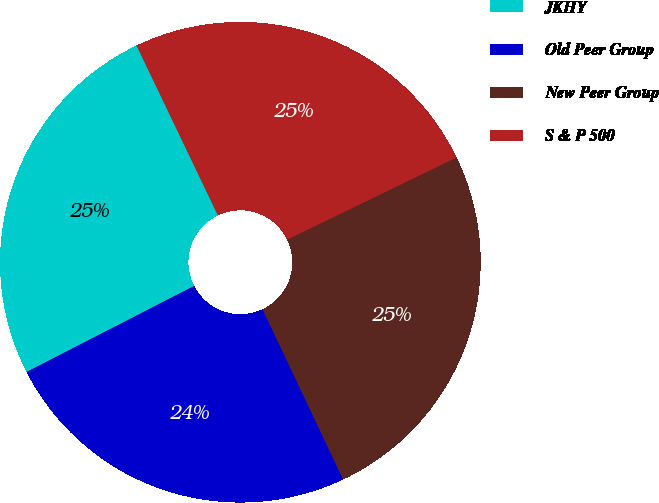Convert chart to OTSL. <chart><loc_0><loc_0><loc_500><loc_500><pie_chart><fcel>JKHY<fcel>Old Peer Group<fcel>New Peer Group<fcel>S & P 500<nl><fcel>25.44%<fcel>24.49%<fcel>25.15%<fcel>24.92%<nl></chart> 